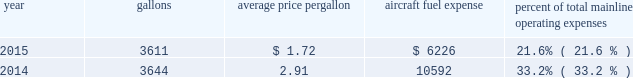Table of contents certain union-represented american mainline employees are covered by agreements that are not currently amendable .
Until those agreements become amendable , negotiations for jcbas will be conducted outside the traditional rla bargaining process described above , and , in the meantime , no self-help will be permissible .
The piedmont mechanics and stock clerks and the psa dispatchers have agreements that are now amendable and are engaged in traditional rla negotiations .
None of the unions representing our employees presently may lawfully engage in concerted refusals to work , such as strikes , slow-downs , sick-outs or other similar activity , against us .
Nonetheless , there is a risk that disgruntled employees , either with or without union involvement , could engage in one or more concerted refusals to work that could individually or collectively harm the operation of our airline and impair our financial performance .
For more discussion , see part i , item 1a .
Risk factors 2013 201cunion disputes , employee strikes and other labor-related disruptions may adversely affect our operations . 201d aircraft fuel our operations and financial results are significantly affected by the availability and price of jet fuel .
Based on our 2016 forecasted mainline and regional fuel consumption , we estimate that , as of december 31 , 2015 , a one cent per gallon increase in aviation fuel price would increase our 2016 annual fuel expense by $ 44 million .
The table shows annual aircraft fuel consumption and costs , including taxes , for our mainline operations for 2015 and 2014 ( gallons and aircraft fuel expense in millions ) .
Year gallons average price per gallon aircraft fuel expense percent of total mainline operating expenses .
Total fuel expenses for our wholly-owned and third-party regional carriers operating under capacity purchase agreements of american were $ 1.2 billion and $ 2.0 billion for the years ended december 31 , 2015 and 2014 , respectively .
As of december 31 , 2015 , we did not have any fuel hedging contracts outstanding to hedge our fuel consumption .
As such , and assuming we do not enter into any future transactions to hedge our fuel consumption , we will continue to be fully exposed to fluctuations in fuel prices .
Our current policy is not to enter into transactions to hedge our fuel consumption , although we review that policy from time to time based on market conditions and other factors .
Fuel prices have fluctuated substantially over the past several years .
We cannot predict the future availability , price volatility or cost of aircraft fuel .
Natural disasters , political disruptions or wars involving oil-producing countries , changes in fuel-related governmental policy , the strength of the u.s .
Dollar against foreign currencies , changes in access to petroleum product pipelines and terminals , speculation in the energy futures markets , changes in aircraft fuel production capacity , environmental concerns and other unpredictable events may result in fuel supply shortages , additional fuel price volatility and cost increases in the future .
See part i , item 1a .
Risk factors 2013 201cour business is dependent on the price and availability of aircraft fuel .
Continued periods of high volatility in fuel costs , increased fuel prices and significant disruptions in the supply of aircraft fuel could have a significant negative impact on our operating results and liquidity . 201d insurance we maintain insurance of the types that we believe are customary in the airline industry , including insurance for public liability , passenger liability , property damage , and all-risk coverage for damage to our aircraft .
Principal coverage includes liability for injury to members of the public , including passengers , damage to .
What was total mainline operating expenses for 2014? 
Computations: (10592 / 33.2%)
Answer: 31903.61446. 